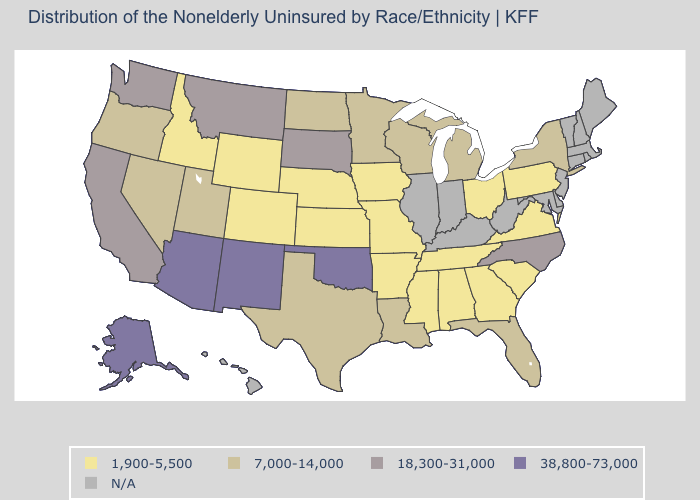What is the value of Arizona?
Quick response, please. 38,800-73,000. What is the highest value in the West ?
Answer briefly. 38,800-73,000. What is the value of Delaware?
Concise answer only. N/A. Name the states that have a value in the range 1,900-5,500?
Give a very brief answer. Alabama, Arkansas, Colorado, Georgia, Idaho, Iowa, Kansas, Mississippi, Missouri, Nebraska, Ohio, Pennsylvania, South Carolina, Tennessee, Virginia, Wyoming. Which states hav the highest value in the Northeast?
Concise answer only. New York. What is the value of Hawaii?
Give a very brief answer. N/A. What is the lowest value in the Northeast?
Short answer required. 1,900-5,500. Does Mississippi have the lowest value in the USA?
Answer briefly. Yes. What is the value of Virginia?
Quick response, please. 1,900-5,500. Which states hav the highest value in the Northeast?
Write a very short answer. New York. Among the states that border New Mexico , does Oklahoma have the lowest value?
Answer briefly. No. What is the highest value in the South ?
Answer briefly. 38,800-73,000. What is the lowest value in states that border Maryland?
Concise answer only. 1,900-5,500. What is the value of Virginia?
Be succinct. 1,900-5,500. 